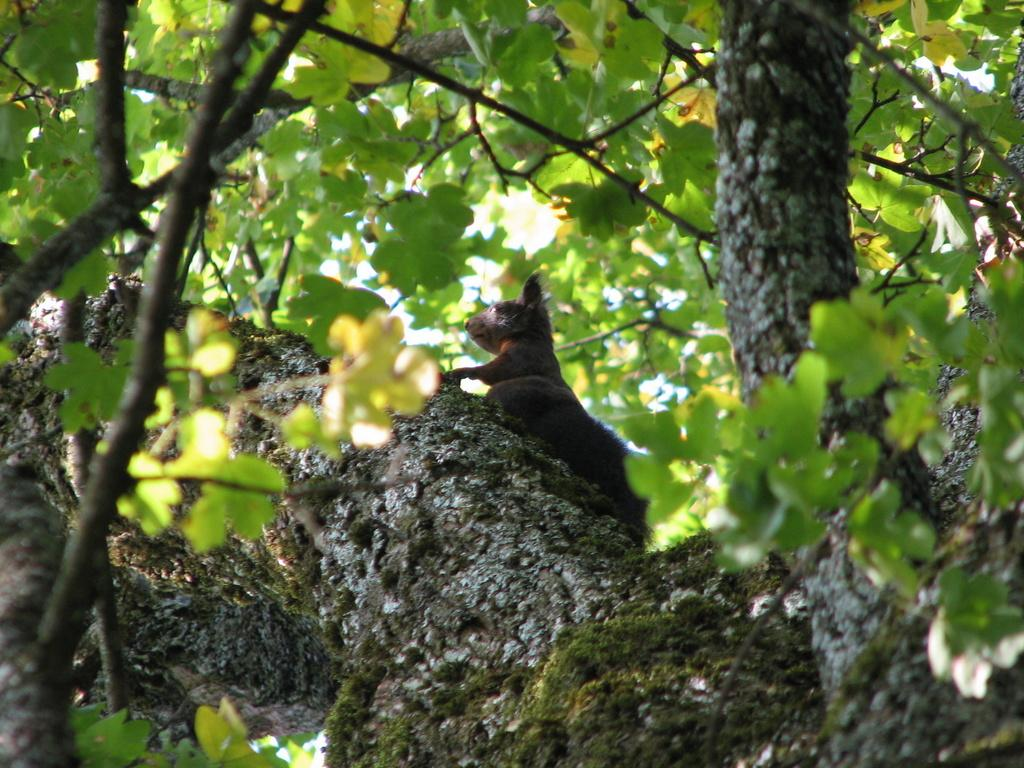What type of animal can be seen in the image? There is an animal in the image, but its specific type cannot be determined from the provided facts. Where is the animal located in the image? The animal is on a tree in the image. What can be seen in the background of the image? There are trees and the sky visible in the background of the image. What language is the animal speaking in the image? Animals do not speak human languages, so it cannot be determined what language the animal is speaking in the image. Can you tell me how many wrens are present in the image? There is no mention of wrens in the provided facts, so it cannot be determined how many wrens are present in the image. 